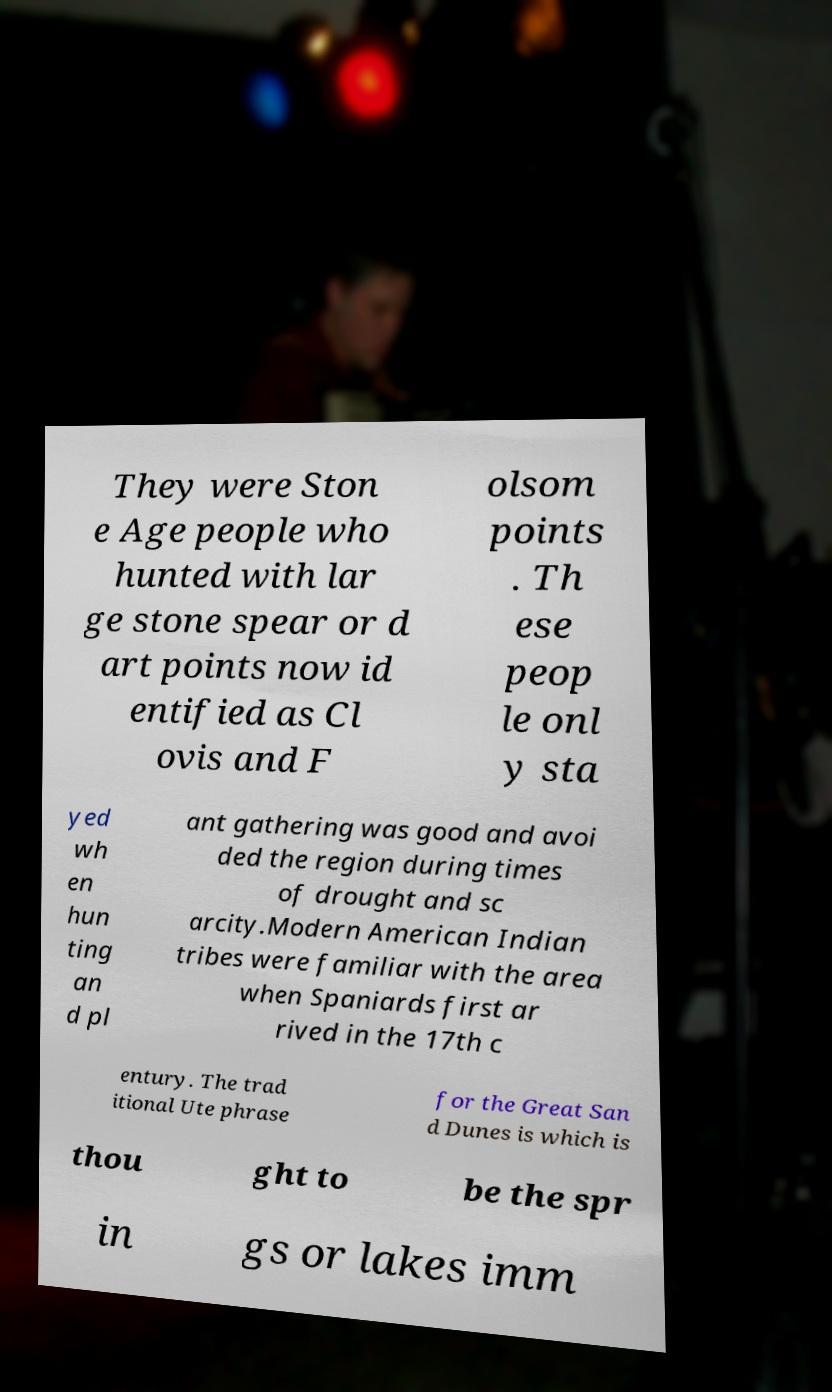For documentation purposes, I need the text within this image transcribed. Could you provide that? They were Ston e Age people who hunted with lar ge stone spear or d art points now id entified as Cl ovis and F olsom points . Th ese peop le onl y sta yed wh en hun ting an d pl ant gathering was good and avoi ded the region during times of drought and sc arcity.Modern American Indian tribes were familiar with the area when Spaniards first ar rived in the 17th c entury. The trad itional Ute phrase for the Great San d Dunes is which is thou ght to be the spr in gs or lakes imm 